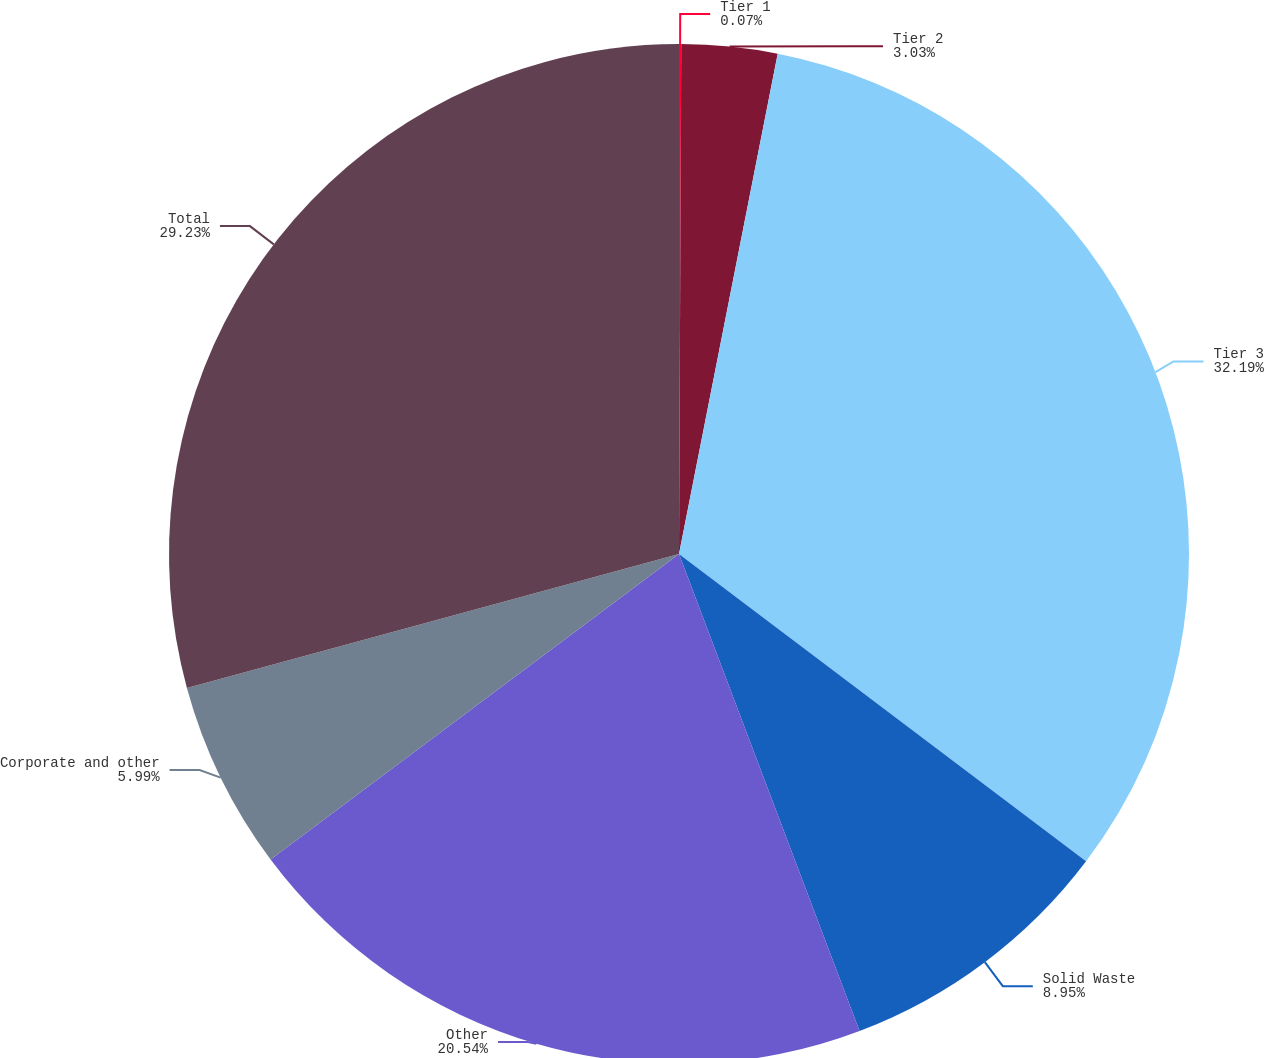Convert chart. <chart><loc_0><loc_0><loc_500><loc_500><pie_chart><fcel>Tier 1<fcel>Tier 2<fcel>Tier 3<fcel>Solid Waste<fcel>Other<fcel>Corporate and other<fcel>Total<nl><fcel>0.07%<fcel>3.03%<fcel>32.19%<fcel>8.95%<fcel>20.54%<fcel>5.99%<fcel>29.23%<nl></chart> 